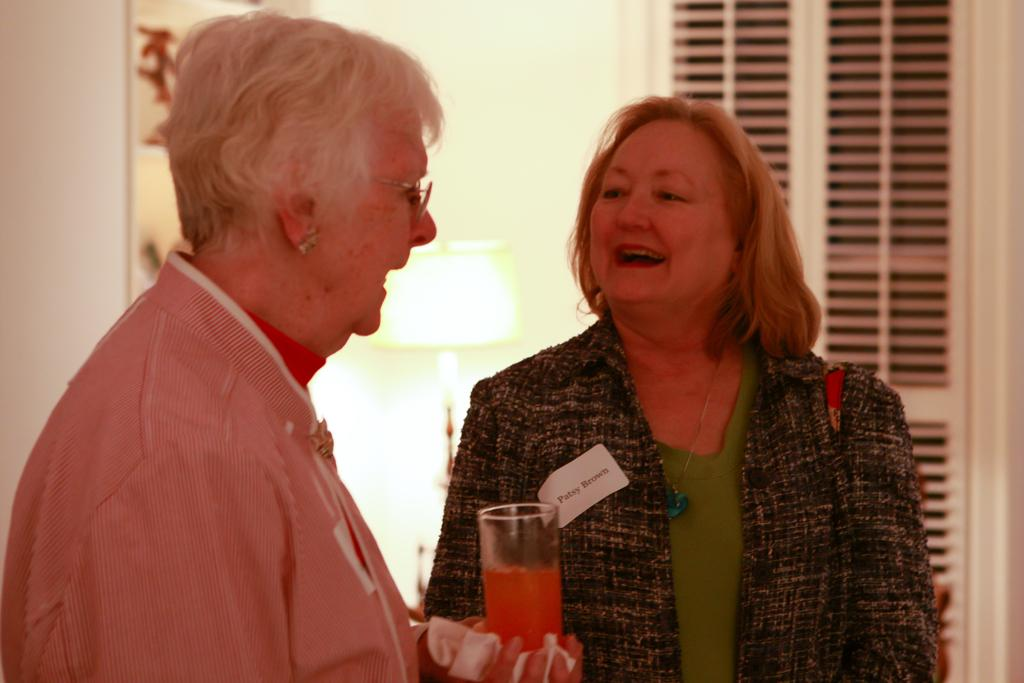How many people are in the image? There are two women in the image. What is the first woman holding? The first woman is holding a glass. What is the emotional state of the women in the image? Both women are laughing. Can you describe the background of the image? The background of the image is blurred. What type of tax is being discussed by the women in the image? There is no indication in the image that the women are discussing any type of tax. Can you see any bats flying in the image? There are no bats visible in the image. 